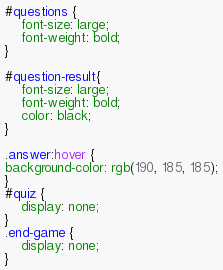<code> <loc_0><loc_0><loc_500><loc_500><_CSS_>#questions {
    font-size: large;
    font-weight: bold;
}

#question-result{
    font-size: large;
    font-weight: bold;
    color: black;
}

.answer:hover {
background-color: rgb(190, 185, 185);
}
#quiz {
    display: none;
}
.end-game {
    display: none;
}
</code> 